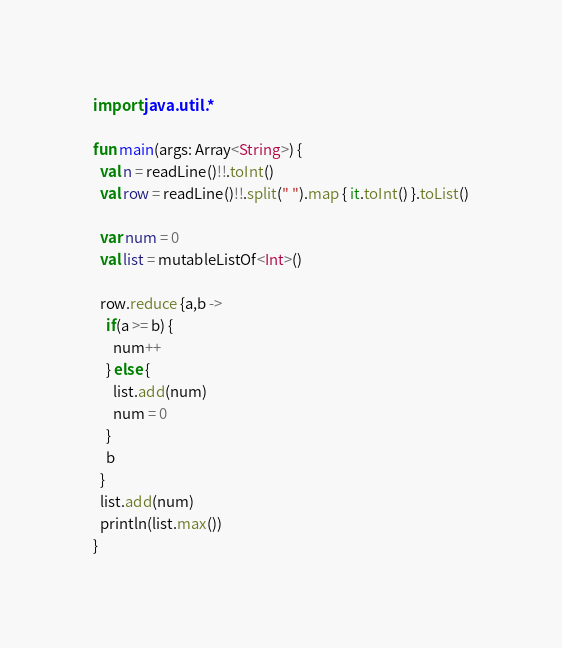<code> <loc_0><loc_0><loc_500><loc_500><_Kotlin_>import java.util.*

fun main(args: Array<String>) {
  val n = readLine()!!.toInt()
  val row = readLine()!!.split(" ").map { it.toInt() }.toList()
  
  var num = 0
  val list = mutableListOf<Int>()

  row.reduce {a,b ->
    if(a >= b) {
      num++
    } else {
      list.add(num)
      num = 0
    }
    b
  }
  list.add(num)
  println(list.max())   
}
</code> 